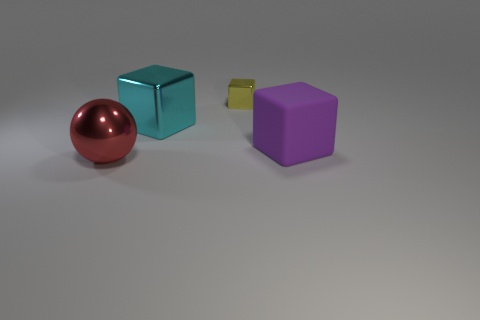Is there anything else that is the same shape as the large red object?
Provide a short and direct response. No. Is the number of large spheres that are behind the large purple object less than the number of big things?
Ensure brevity in your answer.  Yes. There is a block behind the cube to the left of the tiny yellow metallic thing; how big is it?
Ensure brevity in your answer.  Small. What number of objects are small yellow shiny cylinders or small blocks?
Your response must be concise. 1. Are there fewer brown shiny objects than red spheres?
Offer a terse response. Yes. How many things are tiny green cubes or objects that are left of the rubber thing?
Make the answer very short. 3. Are there any balls that have the same material as the purple object?
Offer a terse response. No. There is a cyan object that is the same size as the red thing; what material is it?
Ensure brevity in your answer.  Metal. What is the material of the large cube left of the shiny block behind the cyan object?
Keep it short and to the point. Metal. There is a big object that is behind the large purple matte object; is its shape the same as the big purple matte thing?
Provide a succinct answer. Yes. 